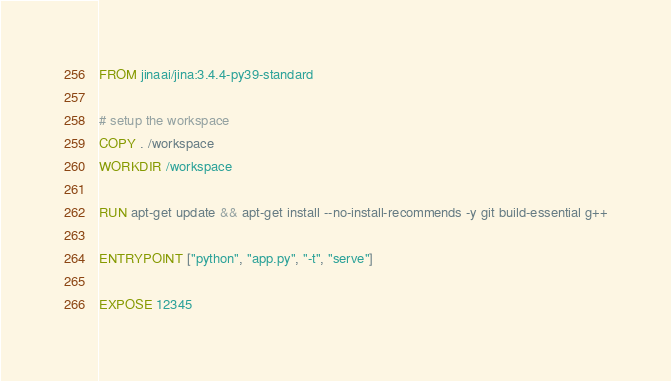Convert code to text. <code><loc_0><loc_0><loc_500><loc_500><_Dockerfile_>FROM jinaai/jina:3.4.4-py39-standard

# setup the workspace
COPY . /workspace
WORKDIR /workspace

RUN apt-get update && apt-get install --no-install-recommends -y git build-essential g++

ENTRYPOINT ["python", "app.py", "-t", "serve"]

EXPOSE 12345
</code> 